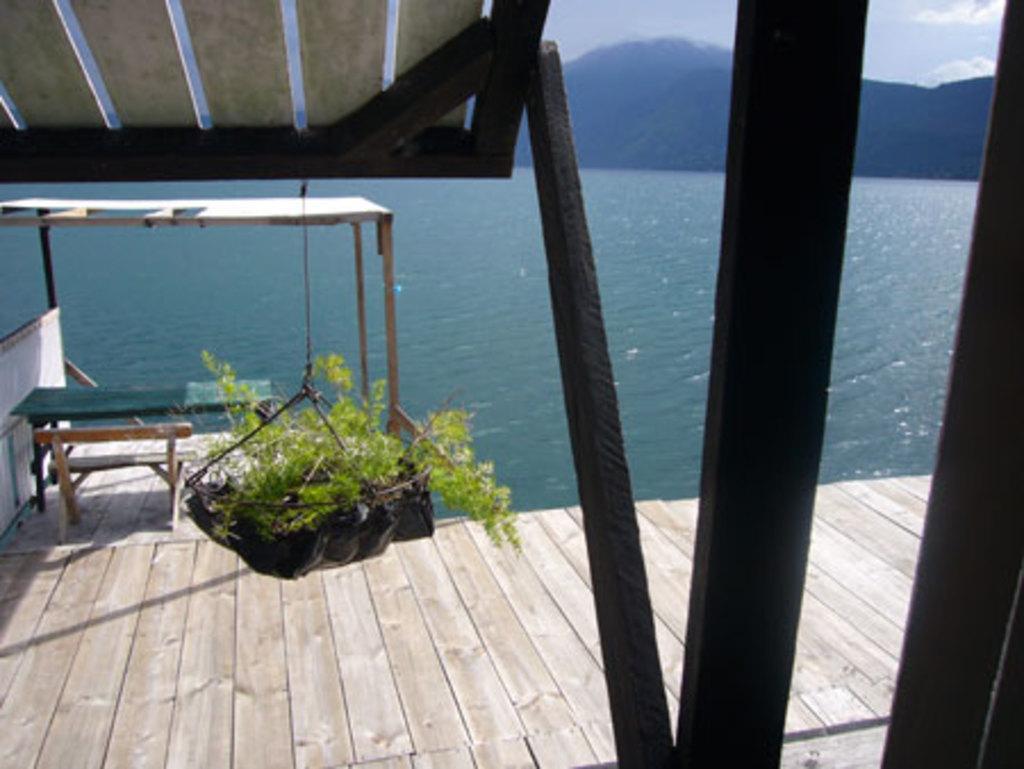In one or two sentences, can you explain what this image depicts? there are so many mountains lake and wooden house there is a bench and chair in it and a hanging pot. 